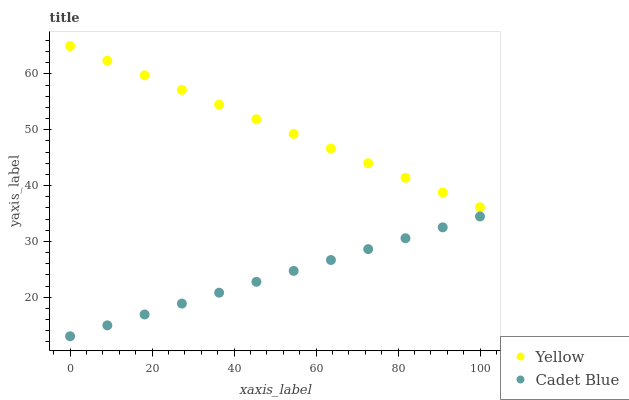Does Cadet Blue have the minimum area under the curve?
Answer yes or no. Yes. Does Yellow have the maximum area under the curve?
Answer yes or no. Yes. Does Yellow have the minimum area under the curve?
Answer yes or no. No. Is Yellow the smoothest?
Answer yes or no. Yes. Is Cadet Blue the roughest?
Answer yes or no. Yes. Is Yellow the roughest?
Answer yes or no. No. Does Cadet Blue have the lowest value?
Answer yes or no. Yes. Does Yellow have the lowest value?
Answer yes or no. No. Does Yellow have the highest value?
Answer yes or no. Yes. Is Cadet Blue less than Yellow?
Answer yes or no. Yes. Is Yellow greater than Cadet Blue?
Answer yes or no. Yes. Does Cadet Blue intersect Yellow?
Answer yes or no. No. 